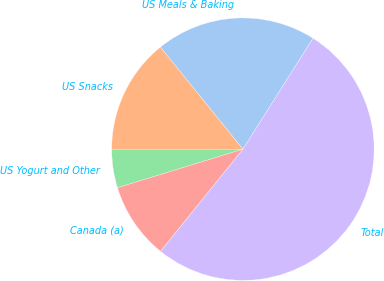<chart> <loc_0><loc_0><loc_500><loc_500><pie_chart><fcel>US Meals & Baking<fcel>US Snacks<fcel>US Yogurt and Other<fcel>Canada (a)<fcel>Total<nl><fcel>19.8%<fcel>14.17%<fcel>4.75%<fcel>9.46%<fcel>51.82%<nl></chart> 